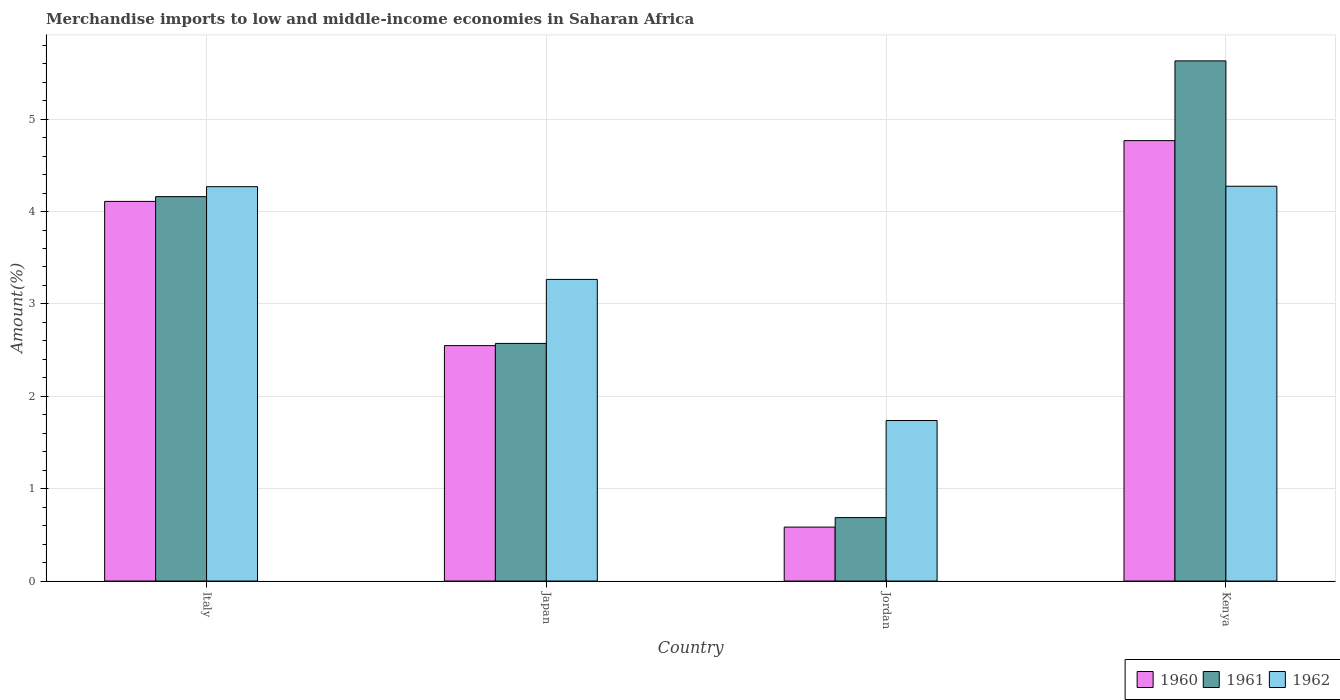Are the number of bars per tick equal to the number of legend labels?
Your response must be concise. Yes. Are the number of bars on each tick of the X-axis equal?
Your answer should be compact. Yes. How many bars are there on the 2nd tick from the right?
Your response must be concise. 3. In how many cases, is the number of bars for a given country not equal to the number of legend labels?
Offer a terse response. 0. What is the percentage of amount earned from merchandise imports in 1961 in Jordan?
Give a very brief answer. 0.69. Across all countries, what is the maximum percentage of amount earned from merchandise imports in 1962?
Keep it short and to the point. 4.27. Across all countries, what is the minimum percentage of amount earned from merchandise imports in 1960?
Offer a terse response. 0.58. In which country was the percentage of amount earned from merchandise imports in 1960 maximum?
Make the answer very short. Kenya. In which country was the percentage of amount earned from merchandise imports in 1962 minimum?
Provide a short and direct response. Jordan. What is the total percentage of amount earned from merchandise imports in 1960 in the graph?
Your answer should be very brief. 12.01. What is the difference between the percentage of amount earned from merchandise imports in 1962 in Italy and that in Jordan?
Offer a terse response. 2.53. What is the difference between the percentage of amount earned from merchandise imports in 1962 in Japan and the percentage of amount earned from merchandise imports in 1960 in Italy?
Offer a very short reply. -0.84. What is the average percentage of amount earned from merchandise imports in 1961 per country?
Your response must be concise. 3.26. What is the difference between the percentage of amount earned from merchandise imports of/in 1961 and percentage of amount earned from merchandise imports of/in 1960 in Kenya?
Ensure brevity in your answer.  0.86. In how many countries, is the percentage of amount earned from merchandise imports in 1961 greater than 3.6 %?
Give a very brief answer. 2. What is the ratio of the percentage of amount earned from merchandise imports in 1960 in Japan to that in Jordan?
Offer a very short reply. 4.37. Is the difference between the percentage of amount earned from merchandise imports in 1961 in Japan and Kenya greater than the difference between the percentage of amount earned from merchandise imports in 1960 in Japan and Kenya?
Your answer should be compact. No. What is the difference between the highest and the second highest percentage of amount earned from merchandise imports in 1960?
Make the answer very short. -2.22. What is the difference between the highest and the lowest percentage of amount earned from merchandise imports in 1960?
Your response must be concise. 4.18. Is the sum of the percentage of amount earned from merchandise imports in 1962 in Japan and Jordan greater than the maximum percentage of amount earned from merchandise imports in 1960 across all countries?
Make the answer very short. Yes. What does the 1st bar from the left in Italy represents?
Ensure brevity in your answer.  1960. What does the 3rd bar from the right in Italy represents?
Keep it short and to the point. 1960. Is it the case that in every country, the sum of the percentage of amount earned from merchandise imports in 1962 and percentage of amount earned from merchandise imports in 1960 is greater than the percentage of amount earned from merchandise imports in 1961?
Make the answer very short. Yes. Are all the bars in the graph horizontal?
Make the answer very short. No. How many countries are there in the graph?
Your response must be concise. 4. What is the difference between two consecutive major ticks on the Y-axis?
Ensure brevity in your answer.  1. Does the graph contain any zero values?
Ensure brevity in your answer.  No. Where does the legend appear in the graph?
Provide a succinct answer. Bottom right. How many legend labels are there?
Offer a terse response. 3. What is the title of the graph?
Make the answer very short. Merchandise imports to low and middle-income economies in Saharan Africa. Does "1966" appear as one of the legend labels in the graph?
Provide a short and direct response. No. What is the label or title of the X-axis?
Make the answer very short. Country. What is the label or title of the Y-axis?
Your answer should be compact. Amount(%). What is the Amount(%) of 1960 in Italy?
Ensure brevity in your answer.  4.11. What is the Amount(%) in 1961 in Italy?
Offer a very short reply. 4.16. What is the Amount(%) of 1962 in Italy?
Make the answer very short. 4.27. What is the Amount(%) of 1960 in Japan?
Your answer should be compact. 2.55. What is the Amount(%) in 1961 in Japan?
Keep it short and to the point. 2.57. What is the Amount(%) in 1962 in Japan?
Provide a succinct answer. 3.27. What is the Amount(%) of 1960 in Jordan?
Provide a short and direct response. 0.58. What is the Amount(%) in 1961 in Jordan?
Offer a terse response. 0.69. What is the Amount(%) in 1962 in Jordan?
Ensure brevity in your answer.  1.74. What is the Amount(%) in 1960 in Kenya?
Your response must be concise. 4.77. What is the Amount(%) of 1961 in Kenya?
Offer a very short reply. 5.63. What is the Amount(%) of 1962 in Kenya?
Keep it short and to the point. 4.27. Across all countries, what is the maximum Amount(%) in 1960?
Offer a very short reply. 4.77. Across all countries, what is the maximum Amount(%) of 1961?
Offer a terse response. 5.63. Across all countries, what is the maximum Amount(%) in 1962?
Give a very brief answer. 4.27. Across all countries, what is the minimum Amount(%) in 1960?
Provide a short and direct response. 0.58. Across all countries, what is the minimum Amount(%) of 1961?
Keep it short and to the point. 0.69. Across all countries, what is the minimum Amount(%) in 1962?
Your answer should be compact. 1.74. What is the total Amount(%) of 1960 in the graph?
Ensure brevity in your answer.  12.01. What is the total Amount(%) in 1961 in the graph?
Your answer should be compact. 13.05. What is the total Amount(%) in 1962 in the graph?
Provide a succinct answer. 13.55. What is the difference between the Amount(%) in 1960 in Italy and that in Japan?
Your answer should be compact. 1.56. What is the difference between the Amount(%) of 1961 in Italy and that in Japan?
Offer a very short reply. 1.59. What is the difference between the Amount(%) in 1960 in Italy and that in Jordan?
Provide a succinct answer. 3.53. What is the difference between the Amount(%) in 1961 in Italy and that in Jordan?
Offer a terse response. 3.47. What is the difference between the Amount(%) in 1962 in Italy and that in Jordan?
Offer a terse response. 2.53. What is the difference between the Amount(%) of 1960 in Italy and that in Kenya?
Offer a very short reply. -0.66. What is the difference between the Amount(%) of 1961 in Italy and that in Kenya?
Offer a very short reply. -1.47. What is the difference between the Amount(%) in 1962 in Italy and that in Kenya?
Ensure brevity in your answer.  -0. What is the difference between the Amount(%) of 1960 in Japan and that in Jordan?
Give a very brief answer. 1.96. What is the difference between the Amount(%) in 1961 in Japan and that in Jordan?
Ensure brevity in your answer.  1.89. What is the difference between the Amount(%) in 1962 in Japan and that in Jordan?
Provide a succinct answer. 1.53. What is the difference between the Amount(%) of 1960 in Japan and that in Kenya?
Offer a very short reply. -2.22. What is the difference between the Amount(%) of 1961 in Japan and that in Kenya?
Your answer should be compact. -3.06. What is the difference between the Amount(%) of 1962 in Japan and that in Kenya?
Your response must be concise. -1.01. What is the difference between the Amount(%) in 1960 in Jordan and that in Kenya?
Your answer should be very brief. -4.18. What is the difference between the Amount(%) of 1961 in Jordan and that in Kenya?
Ensure brevity in your answer.  -4.94. What is the difference between the Amount(%) in 1962 in Jordan and that in Kenya?
Give a very brief answer. -2.54. What is the difference between the Amount(%) in 1960 in Italy and the Amount(%) in 1961 in Japan?
Give a very brief answer. 1.54. What is the difference between the Amount(%) of 1960 in Italy and the Amount(%) of 1962 in Japan?
Your answer should be very brief. 0.84. What is the difference between the Amount(%) in 1961 in Italy and the Amount(%) in 1962 in Japan?
Your answer should be very brief. 0.9. What is the difference between the Amount(%) in 1960 in Italy and the Amount(%) in 1961 in Jordan?
Keep it short and to the point. 3.42. What is the difference between the Amount(%) in 1960 in Italy and the Amount(%) in 1962 in Jordan?
Give a very brief answer. 2.37. What is the difference between the Amount(%) in 1961 in Italy and the Amount(%) in 1962 in Jordan?
Give a very brief answer. 2.42. What is the difference between the Amount(%) of 1960 in Italy and the Amount(%) of 1961 in Kenya?
Offer a terse response. -1.52. What is the difference between the Amount(%) of 1960 in Italy and the Amount(%) of 1962 in Kenya?
Keep it short and to the point. -0.16. What is the difference between the Amount(%) in 1961 in Italy and the Amount(%) in 1962 in Kenya?
Offer a terse response. -0.11. What is the difference between the Amount(%) of 1960 in Japan and the Amount(%) of 1961 in Jordan?
Ensure brevity in your answer.  1.86. What is the difference between the Amount(%) in 1960 in Japan and the Amount(%) in 1962 in Jordan?
Ensure brevity in your answer.  0.81. What is the difference between the Amount(%) in 1961 in Japan and the Amount(%) in 1962 in Jordan?
Give a very brief answer. 0.83. What is the difference between the Amount(%) in 1960 in Japan and the Amount(%) in 1961 in Kenya?
Offer a terse response. -3.08. What is the difference between the Amount(%) of 1960 in Japan and the Amount(%) of 1962 in Kenya?
Offer a very short reply. -1.73. What is the difference between the Amount(%) of 1961 in Japan and the Amount(%) of 1962 in Kenya?
Provide a succinct answer. -1.7. What is the difference between the Amount(%) in 1960 in Jordan and the Amount(%) in 1961 in Kenya?
Ensure brevity in your answer.  -5.05. What is the difference between the Amount(%) in 1960 in Jordan and the Amount(%) in 1962 in Kenya?
Your answer should be compact. -3.69. What is the difference between the Amount(%) in 1961 in Jordan and the Amount(%) in 1962 in Kenya?
Offer a terse response. -3.59. What is the average Amount(%) of 1960 per country?
Provide a succinct answer. 3. What is the average Amount(%) in 1961 per country?
Provide a short and direct response. 3.26. What is the average Amount(%) in 1962 per country?
Give a very brief answer. 3.39. What is the difference between the Amount(%) in 1960 and Amount(%) in 1961 in Italy?
Your answer should be compact. -0.05. What is the difference between the Amount(%) of 1960 and Amount(%) of 1962 in Italy?
Keep it short and to the point. -0.16. What is the difference between the Amount(%) of 1961 and Amount(%) of 1962 in Italy?
Offer a terse response. -0.11. What is the difference between the Amount(%) of 1960 and Amount(%) of 1961 in Japan?
Provide a short and direct response. -0.02. What is the difference between the Amount(%) of 1960 and Amount(%) of 1962 in Japan?
Offer a very short reply. -0.72. What is the difference between the Amount(%) of 1961 and Amount(%) of 1962 in Japan?
Make the answer very short. -0.69. What is the difference between the Amount(%) of 1960 and Amount(%) of 1961 in Jordan?
Make the answer very short. -0.1. What is the difference between the Amount(%) in 1960 and Amount(%) in 1962 in Jordan?
Keep it short and to the point. -1.15. What is the difference between the Amount(%) of 1961 and Amount(%) of 1962 in Jordan?
Provide a succinct answer. -1.05. What is the difference between the Amount(%) of 1960 and Amount(%) of 1961 in Kenya?
Keep it short and to the point. -0.86. What is the difference between the Amount(%) in 1960 and Amount(%) in 1962 in Kenya?
Ensure brevity in your answer.  0.49. What is the difference between the Amount(%) in 1961 and Amount(%) in 1962 in Kenya?
Your answer should be very brief. 1.36. What is the ratio of the Amount(%) in 1960 in Italy to that in Japan?
Your answer should be compact. 1.61. What is the ratio of the Amount(%) in 1961 in Italy to that in Japan?
Your answer should be very brief. 1.62. What is the ratio of the Amount(%) of 1962 in Italy to that in Japan?
Offer a terse response. 1.31. What is the ratio of the Amount(%) of 1960 in Italy to that in Jordan?
Give a very brief answer. 7.04. What is the ratio of the Amount(%) of 1961 in Italy to that in Jordan?
Provide a succinct answer. 6.06. What is the ratio of the Amount(%) in 1962 in Italy to that in Jordan?
Provide a short and direct response. 2.46. What is the ratio of the Amount(%) of 1960 in Italy to that in Kenya?
Offer a terse response. 0.86. What is the ratio of the Amount(%) of 1961 in Italy to that in Kenya?
Give a very brief answer. 0.74. What is the ratio of the Amount(%) of 1962 in Italy to that in Kenya?
Your answer should be very brief. 1. What is the ratio of the Amount(%) in 1960 in Japan to that in Jordan?
Keep it short and to the point. 4.37. What is the ratio of the Amount(%) in 1961 in Japan to that in Jordan?
Your answer should be compact. 3.75. What is the ratio of the Amount(%) in 1962 in Japan to that in Jordan?
Keep it short and to the point. 1.88. What is the ratio of the Amount(%) of 1960 in Japan to that in Kenya?
Give a very brief answer. 0.53. What is the ratio of the Amount(%) of 1961 in Japan to that in Kenya?
Offer a terse response. 0.46. What is the ratio of the Amount(%) of 1962 in Japan to that in Kenya?
Make the answer very short. 0.76. What is the ratio of the Amount(%) in 1960 in Jordan to that in Kenya?
Your response must be concise. 0.12. What is the ratio of the Amount(%) in 1961 in Jordan to that in Kenya?
Provide a short and direct response. 0.12. What is the ratio of the Amount(%) in 1962 in Jordan to that in Kenya?
Your answer should be very brief. 0.41. What is the difference between the highest and the second highest Amount(%) of 1960?
Keep it short and to the point. 0.66. What is the difference between the highest and the second highest Amount(%) of 1961?
Your answer should be very brief. 1.47. What is the difference between the highest and the second highest Amount(%) in 1962?
Keep it short and to the point. 0. What is the difference between the highest and the lowest Amount(%) of 1960?
Provide a short and direct response. 4.18. What is the difference between the highest and the lowest Amount(%) of 1961?
Keep it short and to the point. 4.94. What is the difference between the highest and the lowest Amount(%) in 1962?
Offer a very short reply. 2.54. 